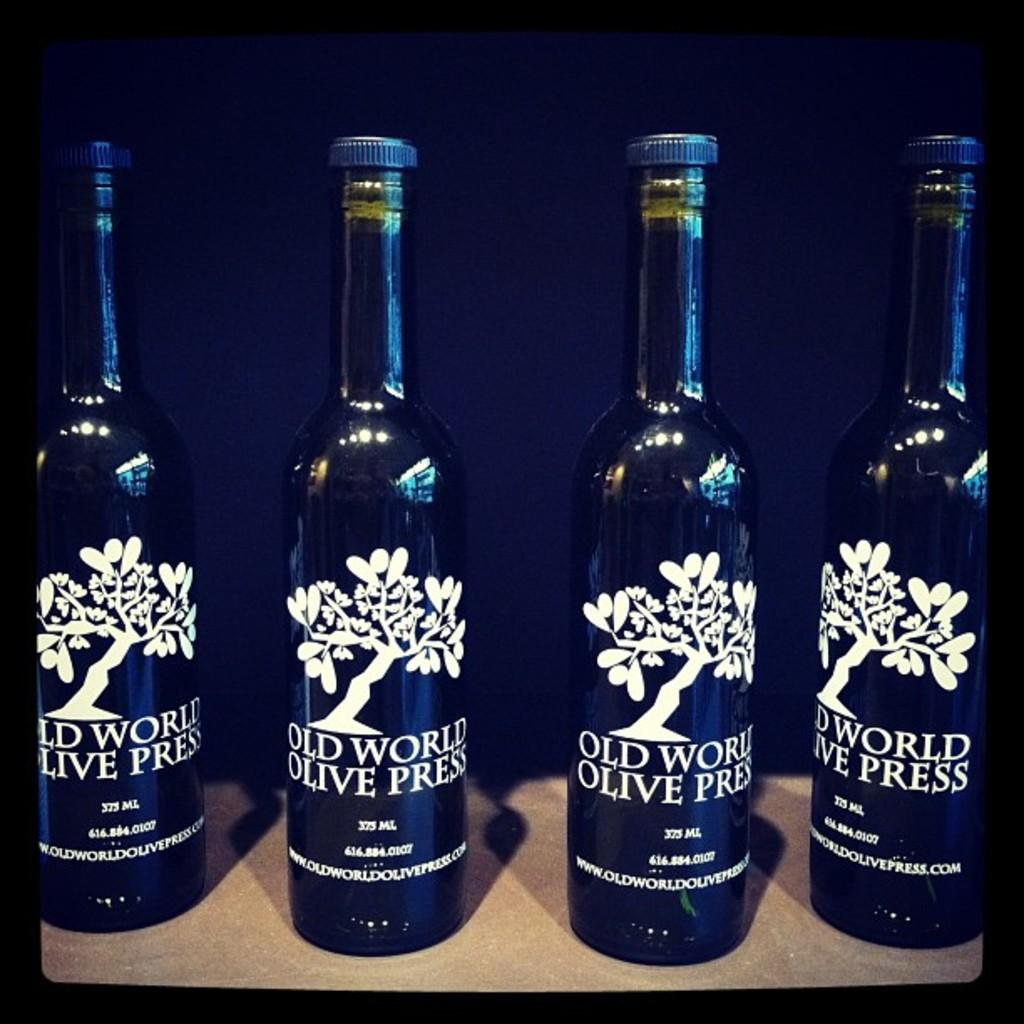<image>
Summarize the visual content of the image. Four bottles of a drink called old world olive press. 